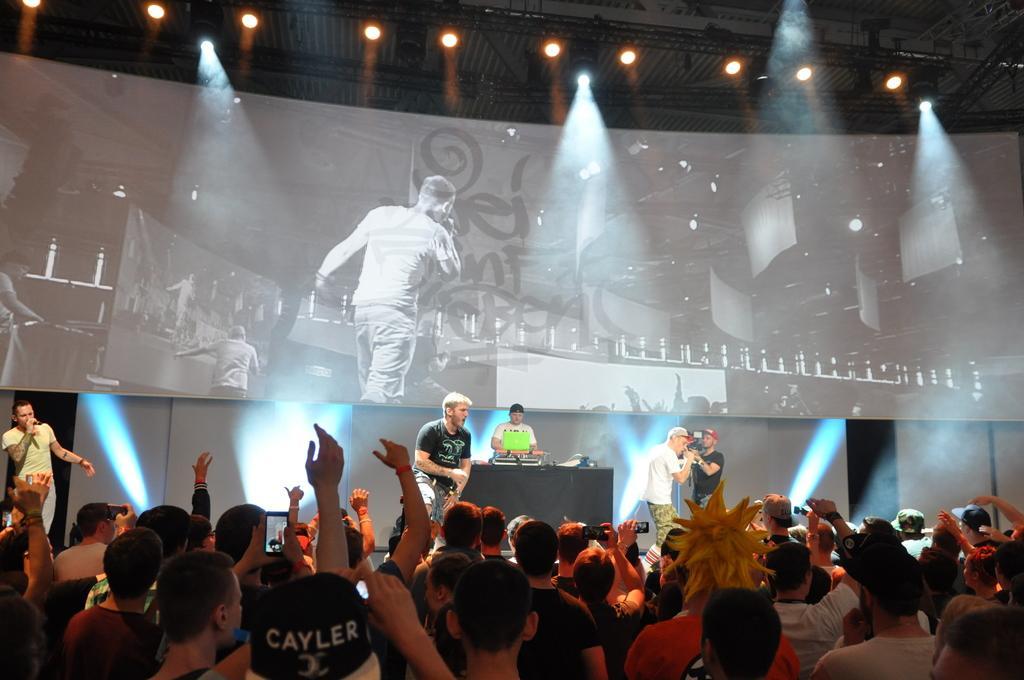Could you give a brief overview of what you see in this image? In the center of the image there are people holding the mikes. There is a person holding the camera. Behind them there is a person standing in front of the table. On top of it there are a few objects. In front of the image there are people holding the mobiles. In the background of the image there is a screen. On top of the image there are lights. 